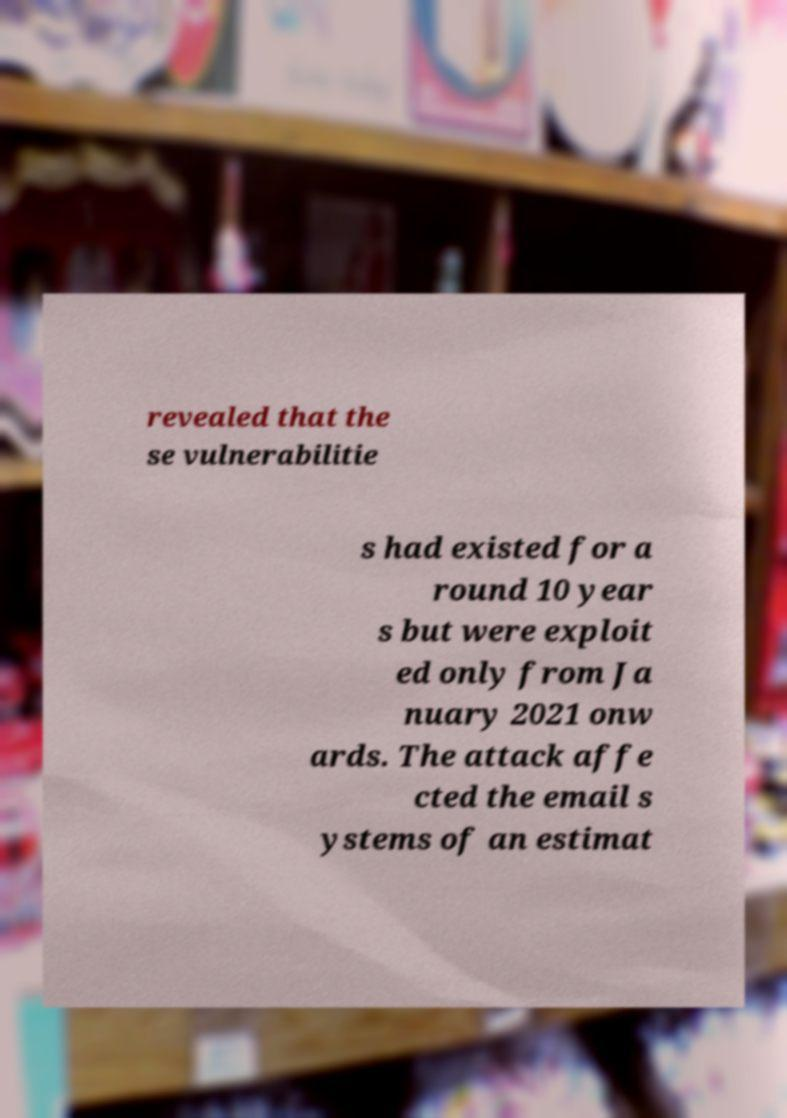Could you extract and type out the text from this image? revealed that the se vulnerabilitie s had existed for a round 10 year s but were exploit ed only from Ja nuary 2021 onw ards. The attack affe cted the email s ystems of an estimat 